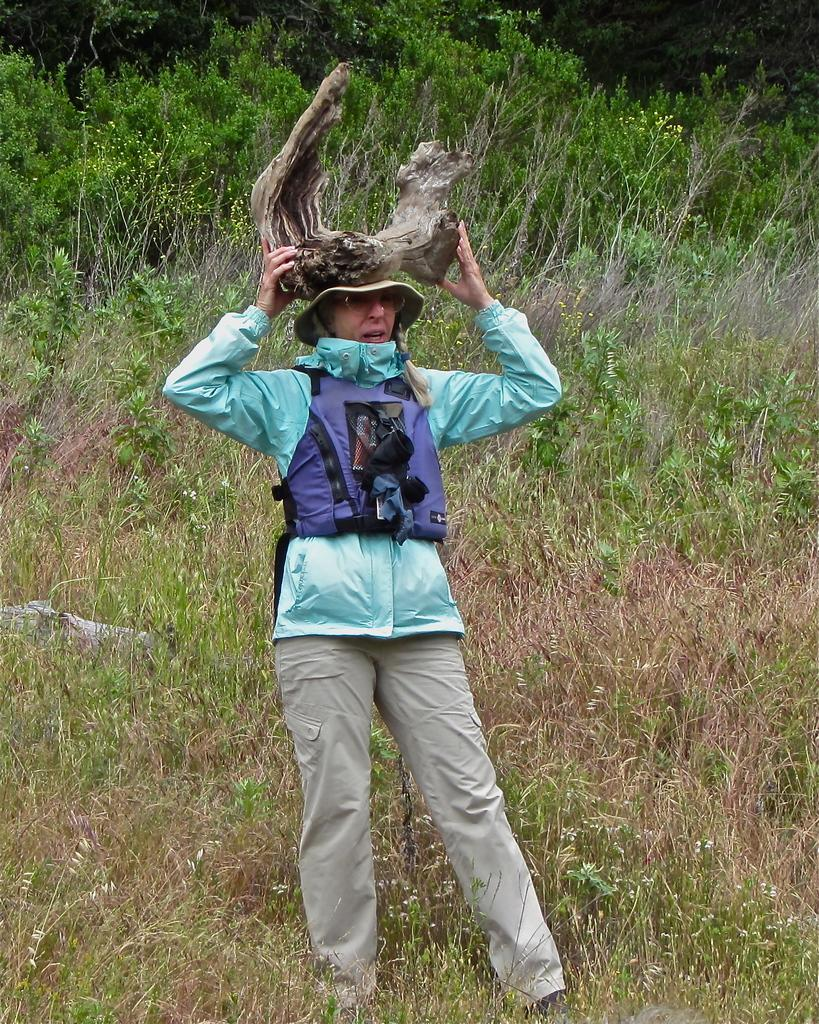What can be seen in the image? There is a person in the image. Can you describe the person's clothing? The person is wearing a dress with green, blue, and cream colors. What is the person holding in the image? The person is holding an object. What is visible in the background of the image? There is grass and trees in the background of the image. What type of base can be seen supporting the zebra in the image? There is no zebra or base present in the image. What scientific discovery is the person making in the image? The image does not depict a scientific discovery; it simply shows a person wearing a dress and holding an object. 